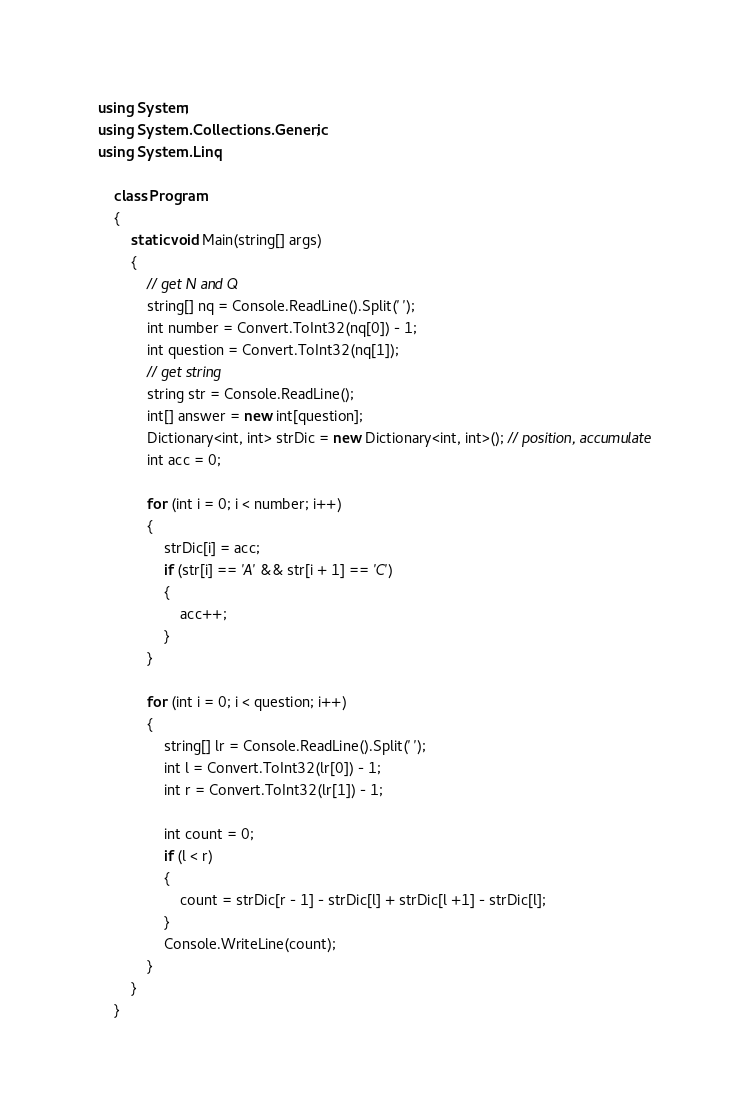<code> <loc_0><loc_0><loc_500><loc_500><_C#_>using System;
using System.Collections.Generic;
using System.Linq;

    class Program
    {
        static void Main(string[] args)
        {
            // get N and Q
            string[] nq = Console.ReadLine().Split(' ');
            int number = Convert.ToInt32(nq[0]) - 1;
            int question = Convert.ToInt32(nq[1]);
            // get string
            string str = Console.ReadLine();
            int[] answer = new int[question];
            Dictionary<int, int> strDic = new Dictionary<int, int>(); // position, accumulate
            int acc = 0;

            for (int i = 0; i < number; i++)
            {
                strDic[i] = acc;
                if (str[i] == 'A' && str[i + 1] == 'C')
                {
                    acc++;
                }
            }

            for (int i = 0; i < question; i++)
            {
                string[] lr = Console.ReadLine().Split(' ');
                int l = Convert.ToInt32(lr[0]) - 1;
                int r = Convert.ToInt32(lr[1]) - 1;

                int count = 0;
                if (l < r)
                {
                    count = strDic[r - 1] - strDic[l] + strDic[l +1] - strDic[l];
                }
                Console.WriteLine(count);
            }
        }
    }</code> 